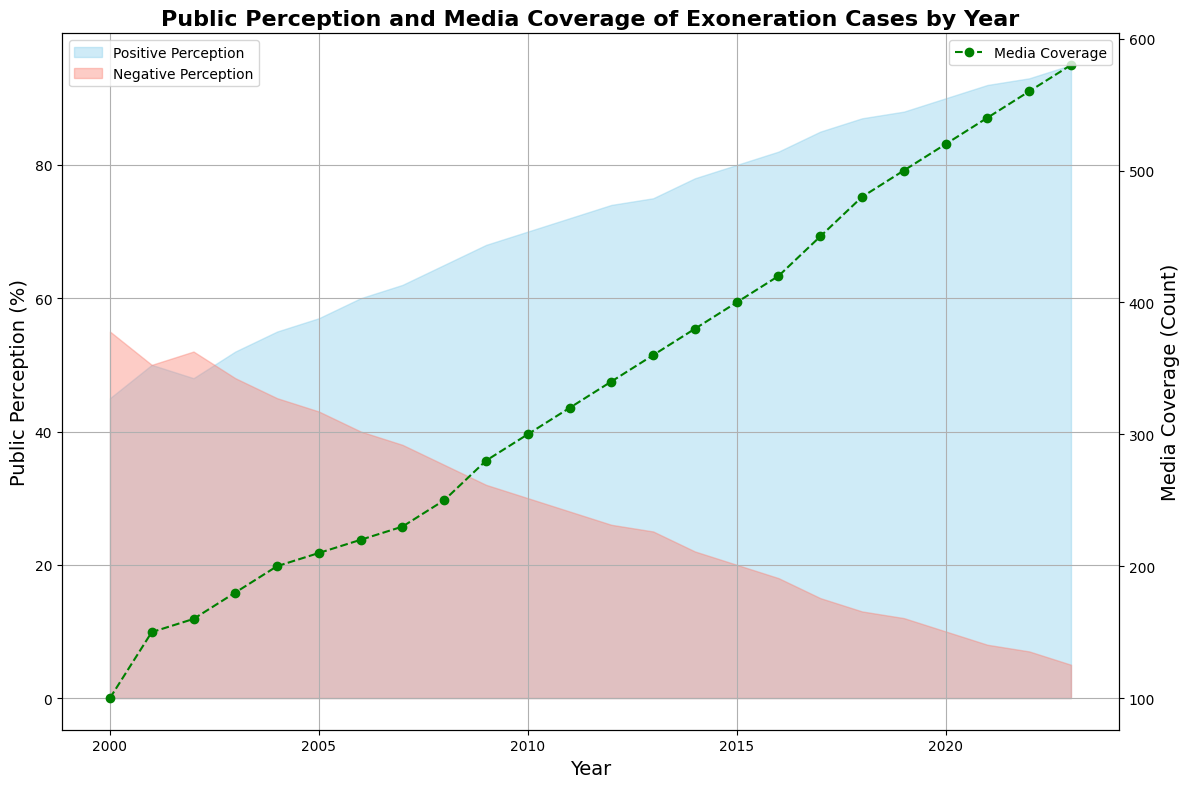What's the trend in positive public perception from 2000 to 2023? The positive public perception starts at 45% in 2000 and gradually increases to 95% in 2023.
Answer: Increasing How does the media coverage trend correlate with public perception? Media coverage also shows an increasing trend, starting from 100 in 2000 to 580 in 2023, which correlates with the increasing positive public perception.
Answer: Positive correlation In which year did the negative public perception drop below 15%? The negative public perception dropped below 15% in 2017.
Answer: 2017 Compare the public perception in 2005 and 2010. In 2005, the positive perception was 57% and negative was 43%. In 2010, positive perception increased to 70% and negative decreased to 30%.
Answer: Increase in positive, decrease in negative Which year has the highest media coverage? The year 2023 has the highest media coverage with a count of 580.
Answer: 2023 What is the difference in positive public perception between 2000 and 2023? In 2000, the positive perception was 45%. In 2023, it was 95%. The difference is 95% - 45% = 50%.
Answer: 50% Describe the visual difference between the area representing positive and negative perceptions in 2010. In 2010, the area representing positive perception (sky blue) is larger than the area representing negative perception (salmon) as positive is at 70% and negative is at 30%.
Answer: Positive area is larger Which year witnessed the sharpest increase in media coverage? Between 2017 and 2018, media coverage increases from 450 to 480, the sharpest yearly increase observed.
Answer: 2017-2018 On average, how has the media coverage changed per year from 2000 to 2023? Total increase in media coverage is 480 (580 in 2023 - 100 in 2000). There are 23 years between 2000 and 2023. Average change per year is 480 / 23 ≈ 20.87.
Answer: 20.87 